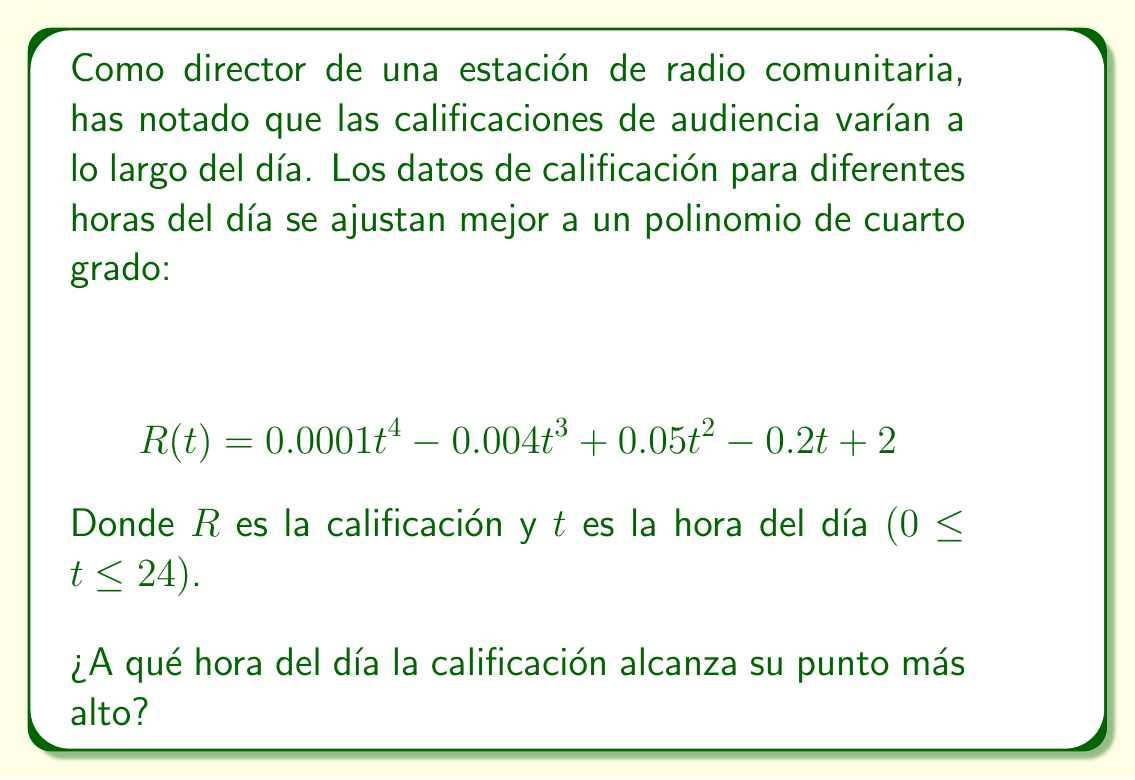Give your solution to this math problem. Para encontrar el punto más alto de la calificación, necesitamos encontrar el máximo de la función $R(t)$. Esto se hace siguiendo estos pasos:

1) Primero, calculamos la derivada de $R(t)$:
   $$ R'(t) = 0.0004t^3 - 0.012t^2 + 0.1t - 0.2 $$

2) Igualamos la derivada a cero para encontrar los puntos críticos:
   $$ 0.0004t^3 - 0.012t^2 + 0.1t - 0.2 = 0 $$

3) Esta ecuación es difícil de resolver a mano, así que usaremos métodos numéricos o una calculadora gráfica para encontrar las soluciones. Las soluciones son aproximadamente:
   $t ≈ 2.39, 10.61, 16.99$

4) Evaluamos $R''(t)$ en estos puntos para determinar cuál es un máximo:
   $$ R''(t) = 0.0012t^2 - 0.024t + 0.1 $$
   
   Para $t = 2.39$: $R''(2.39) > 0$ (mínimo local)
   Para $t = 10.61$: $R''(10.61) < 0$ (máximo local)
   Para $t = 16.99$: $R''(16.99) > 0$ (mínimo local)

5) Por lo tanto, el máximo ocurre cuando $t ≈ 10.61$.

6) Convertimos 10.61 a horas y minutos: 10 horas y 0.61 * 60 ≈ 37 minutos.
Answer: La calificación alcanza su punto más alto aproximadamente a las 10:37 de la mañana. 